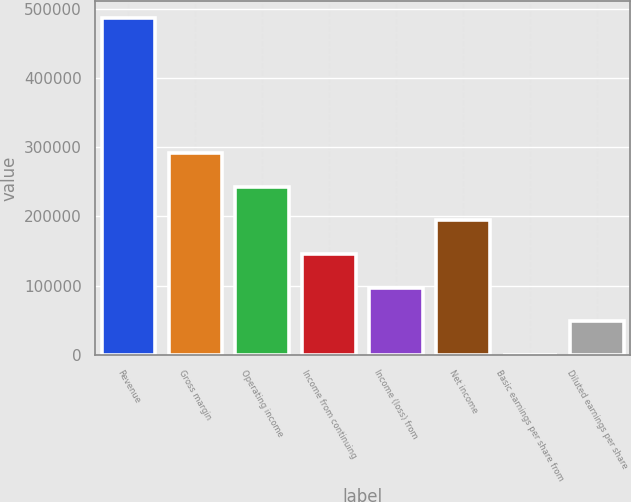<chart> <loc_0><loc_0><loc_500><loc_500><bar_chart><fcel>Revenue<fcel>Gross margin<fcel>Operating income<fcel>Income from continuing<fcel>Income (loss) from<fcel>Net income<fcel>Basic earnings per share from<fcel>Diluted earnings per share<nl><fcel>486355<fcel>291813<fcel>243178<fcel>145907<fcel>97271.2<fcel>194542<fcel>0.2<fcel>48635.7<nl></chart> 